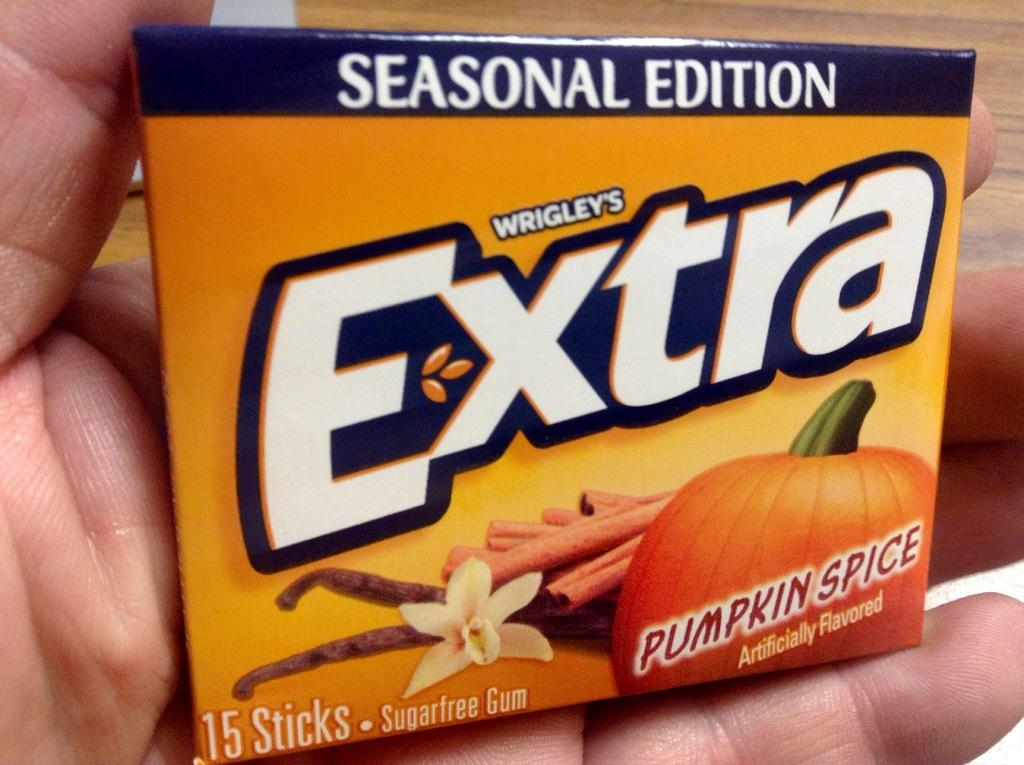<image>
Render a clear and concise summary of the photo. Wrigley's has made a seasonal version of Extra gum that is pumpkin spice flavored. 